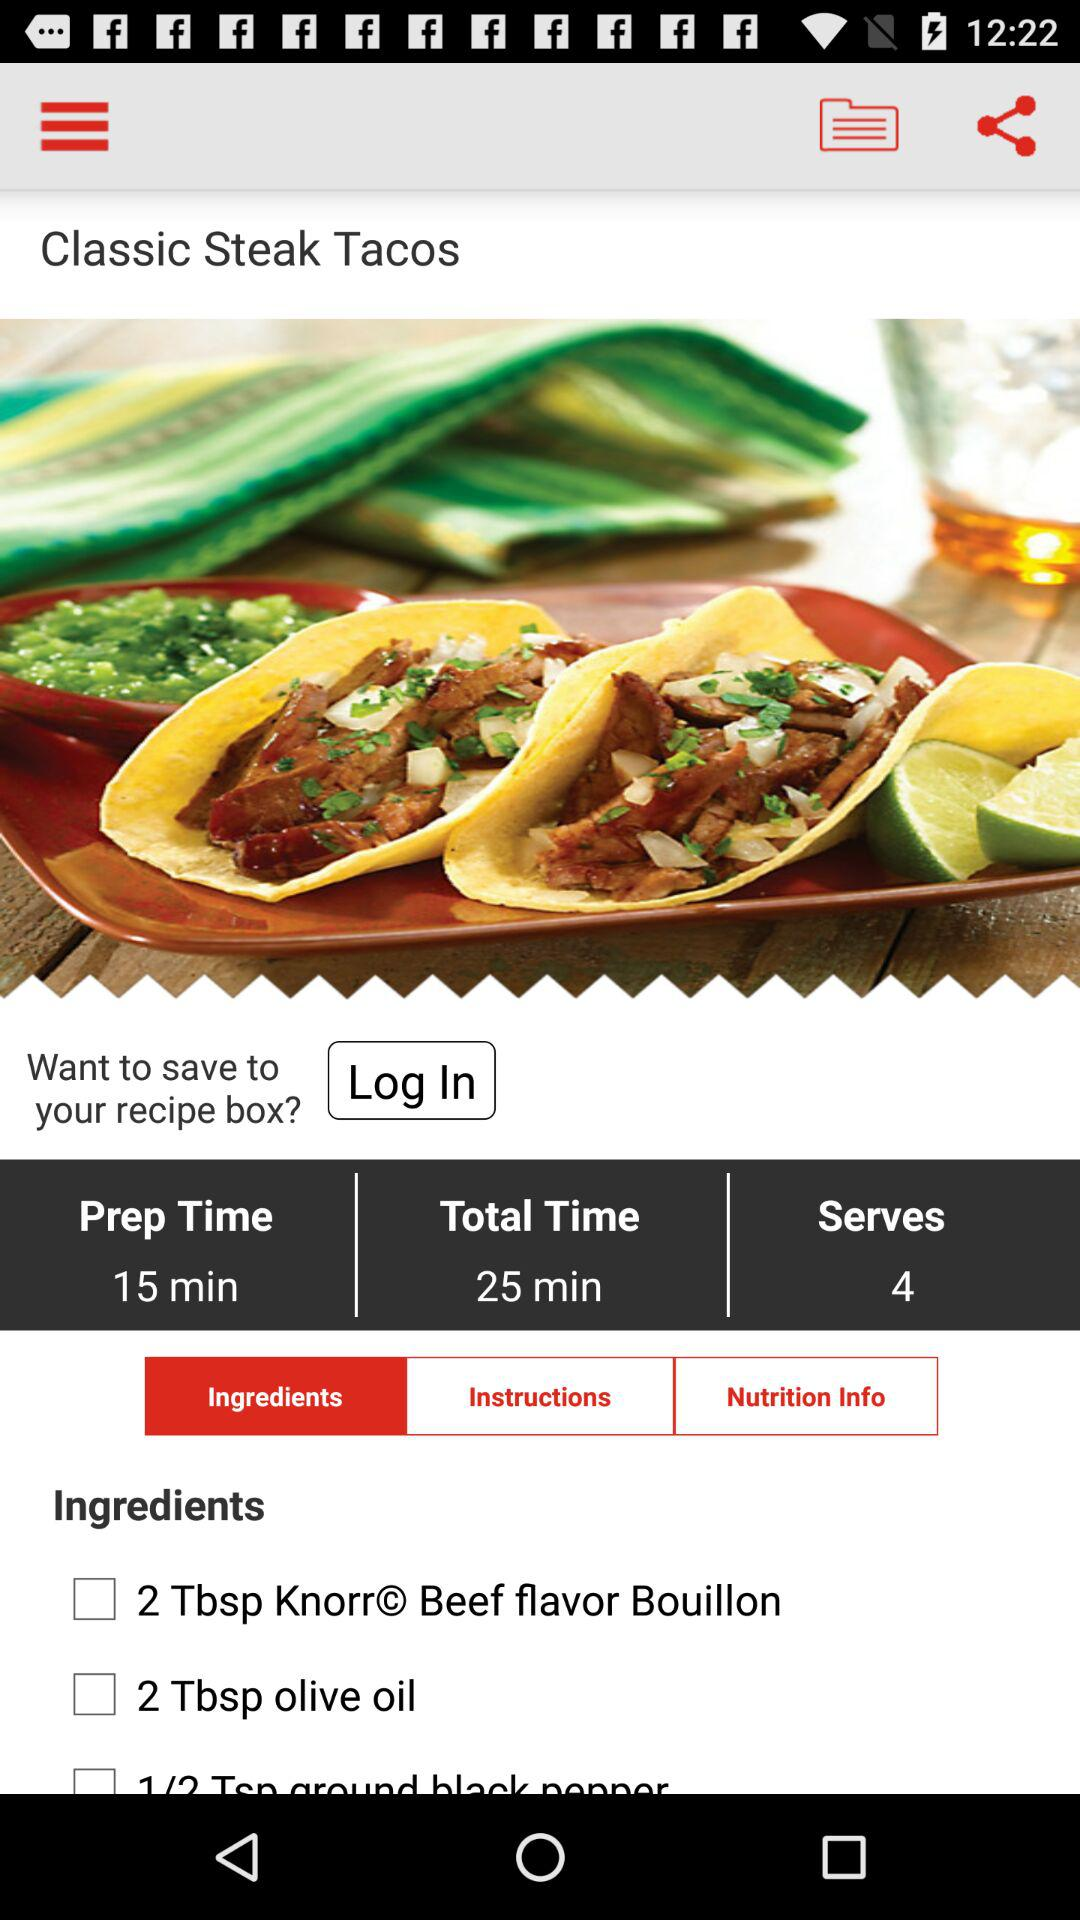How much time is needed to prepare the "Classic Steak Tacos"? The time needed to prepare the "Classic Steak Tacos" is 15 minutes. 